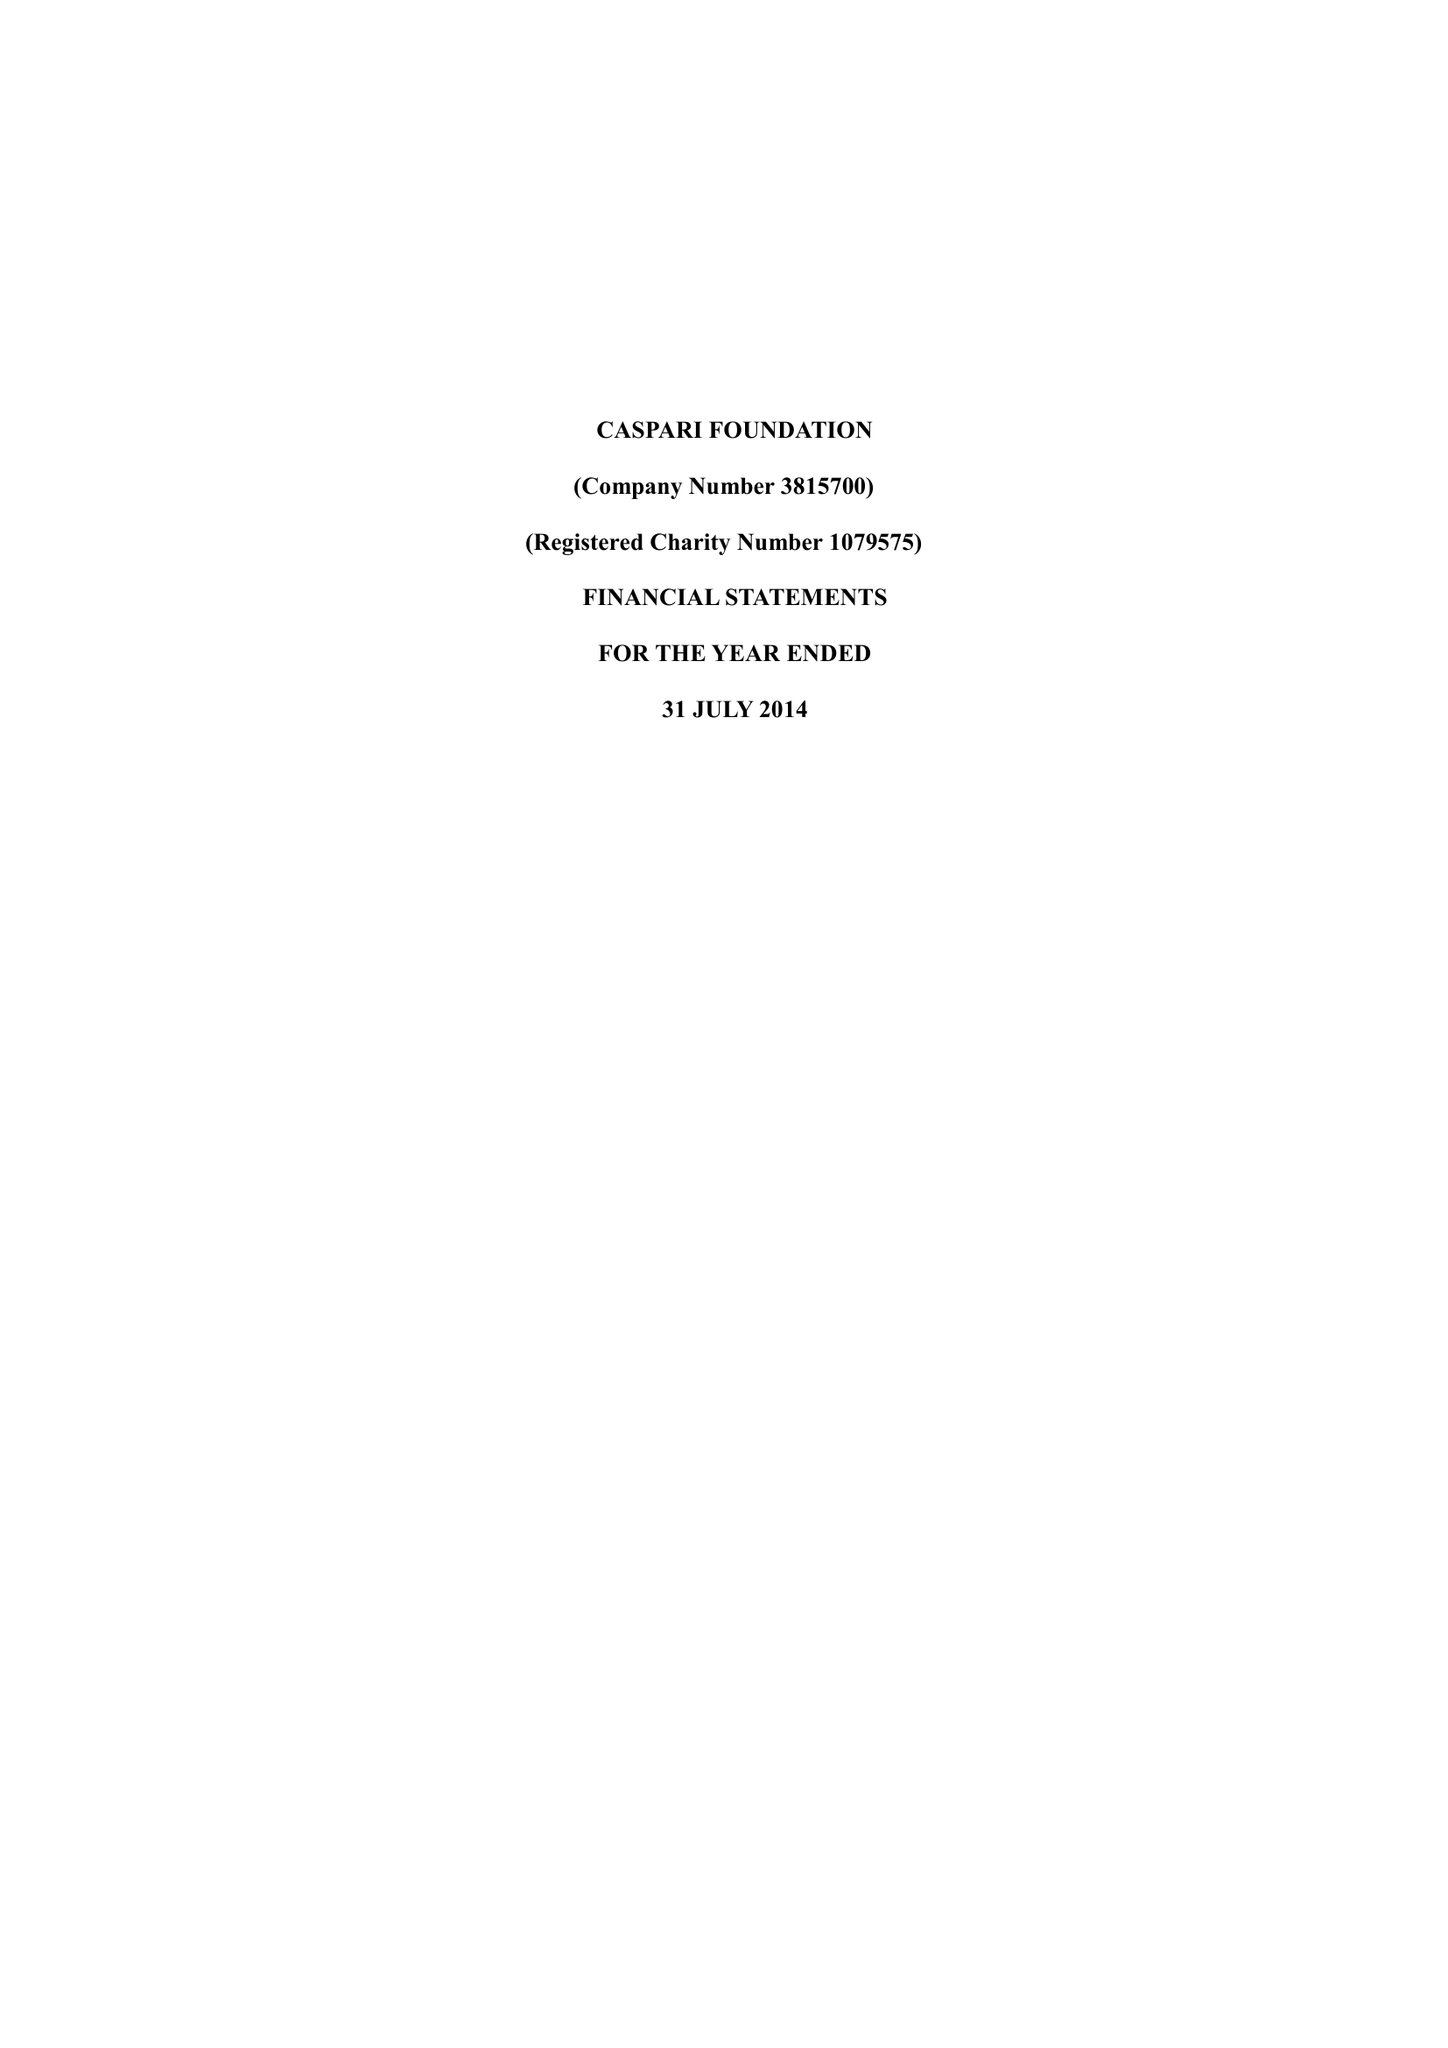What is the value for the charity_number?
Answer the question using a single word or phrase. 1079575 